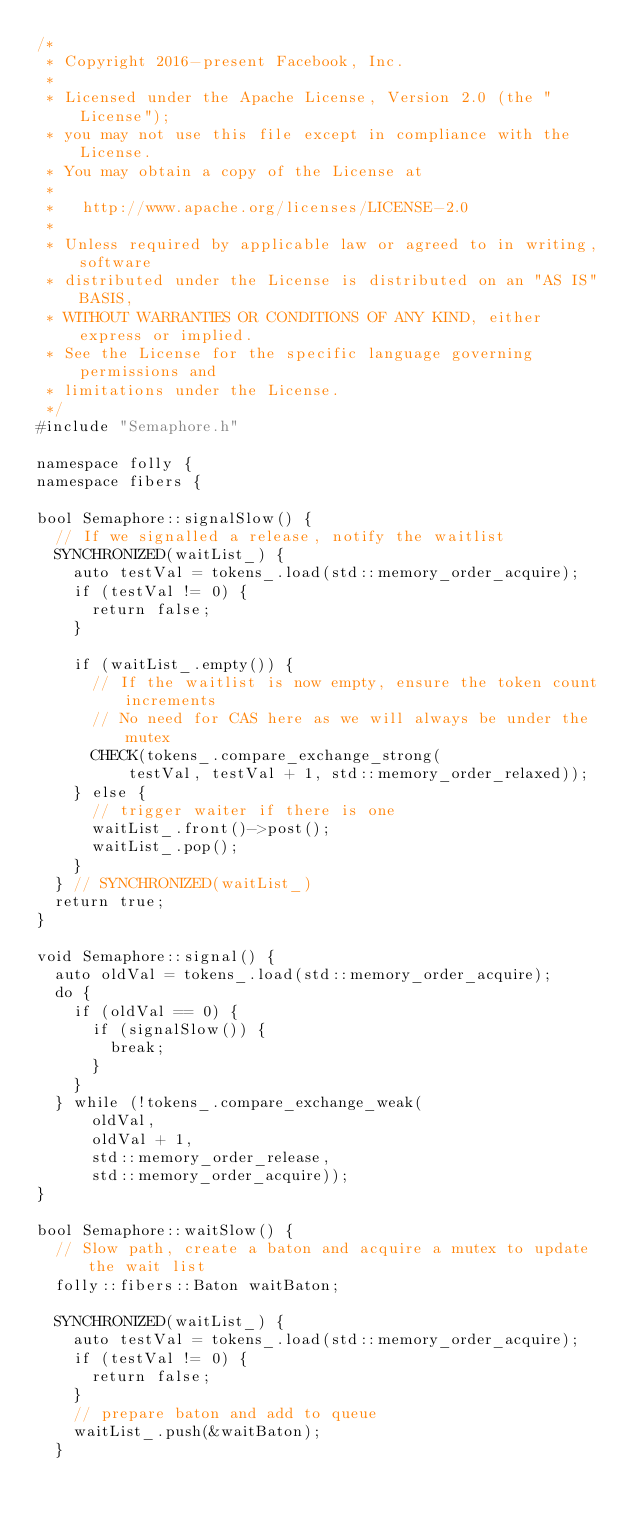Convert code to text. <code><loc_0><loc_0><loc_500><loc_500><_C++_>/*
 * Copyright 2016-present Facebook, Inc.
 *
 * Licensed under the Apache License, Version 2.0 (the "License");
 * you may not use this file except in compliance with the License.
 * You may obtain a copy of the License at
 *
 *   http://www.apache.org/licenses/LICENSE-2.0
 *
 * Unless required by applicable law or agreed to in writing, software
 * distributed under the License is distributed on an "AS IS" BASIS,
 * WITHOUT WARRANTIES OR CONDITIONS OF ANY KIND, either express or implied.
 * See the License for the specific language governing permissions and
 * limitations under the License.
 */
#include "Semaphore.h"

namespace folly {
namespace fibers {

bool Semaphore::signalSlow() {
  // If we signalled a release, notify the waitlist
  SYNCHRONIZED(waitList_) {
    auto testVal = tokens_.load(std::memory_order_acquire);
    if (testVal != 0) {
      return false;
    }

    if (waitList_.empty()) {
      // If the waitlist is now empty, ensure the token count increments
      // No need for CAS here as we will always be under the mutex
      CHECK(tokens_.compare_exchange_strong(
          testVal, testVal + 1, std::memory_order_relaxed));
    } else {
      // trigger waiter if there is one
      waitList_.front()->post();
      waitList_.pop();
    }
  } // SYNCHRONIZED(waitList_)
  return true;
}

void Semaphore::signal() {
  auto oldVal = tokens_.load(std::memory_order_acquire);
  do {
    if (oldVal == 0) {
      if (signalSlow()) {
        break;
      }
    }
  } while (!tokens_.compare_exchange_weak(
      oldVal,
      oldVal + 1,
      std::memory_order_release,
      std::memory_order_acquire));
}

bool Semaphore::waitSlow() {
  // Slow path, create a baton and acquire a mutex to update the wait list
  folly::fibers::Baton waitBaton;

  SYNCHRONIZED(waitList_) {
    auto testVal = tokens_.load(std::memory_order_acquire);
    if (testVal != 0) {
      return false;
    }
    // prepare baton and add to queue
    waitList_.push(&waitBaton);
  }</code> 